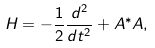<formula> <loc_0><loc_0><loc_500><loc_500>H = - \frac { 1 } { 2 } \frac { d ^ { 2 } } { d t ^ { 2 } } + A ^ { * } A ,</formula> 